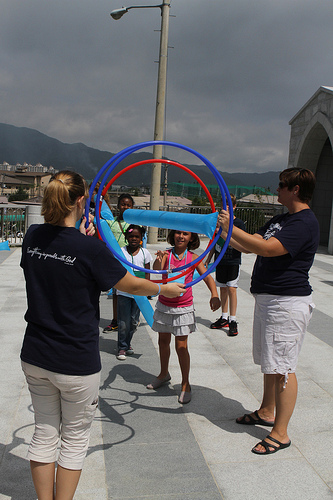<image>
Is there a women to the left of the light? Yes. From this viewpoint, the women is positioned to the left side relative to the light. Is the woman behind the girl? No. The woman is not behind the girl. From this viewpoint, the woman appears to be positioned elsewhere in the scene. 